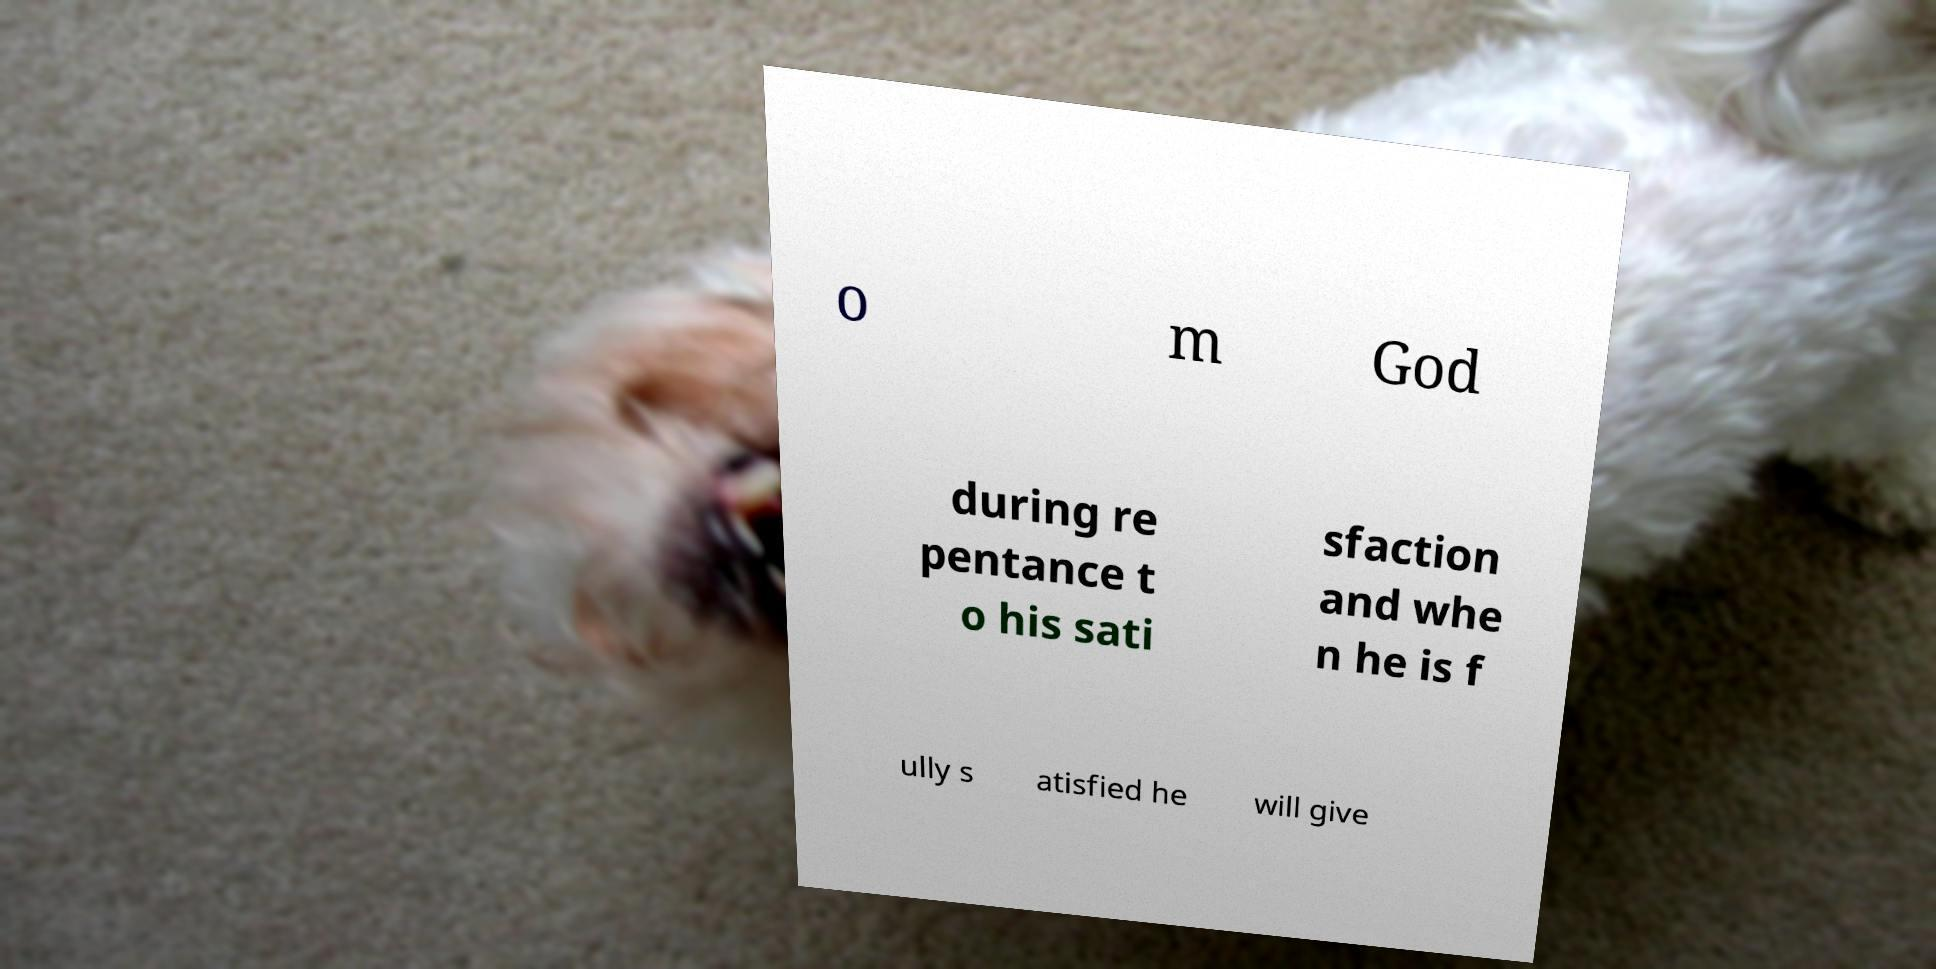What messages or text are displayed in this image? I need them in a readable, typed format. o m God during re pentance t o his sati sfaction and whe n he is f ully s atisfied he will give 